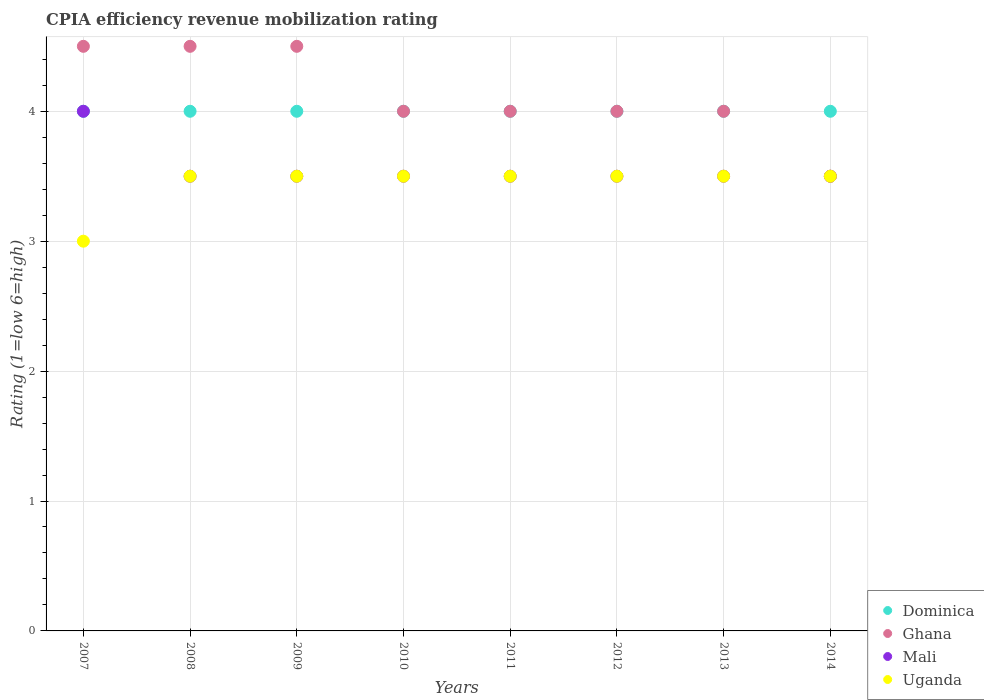How many different coloured dotlines are there?
Your answer should be very brief. 4. Across all years, what is the maximum CPIA rating in Dominica?
Your answer should be compact. 4. Across all years, what is the minimum CPIA rating in Dominica?
Offer a terse response. 4. In which year was the CPIA rating in Dominica minimum?
Keep it short and to the point. 2007. What is the difference between the CPIA rating in Uganda in 2013 and the CPIA rating in Dominica in 2012?
Offer a very short reply. -0.5. What is the average CPIA rating in Uganda per year?
Your answer should be very brief. 3.44. In the year 2011, what is the difference between the CPIA rating in Dominica and CPIA rating in Ghana?
Your answer should be very brief. 0. In how many years, is the CPIA rating in Mali greater than 3.4?
Ensure brevity in your answer.  8. What is the ratio of the CPIA rating in Dominica in 2010 to that in 2013?
Offer a terse response. 1. Is the difference between the CPIA rating in Dominica in 2008 and 2009 greater than the difference between the CPIA rating in Ghana in 2008 and 2009?
Provide a succinct answer. No. What is the difference between the highest and the second highest CPIA rating in Dominica?
Offer a very short reply. 0. Is the sum of the CPIA rating in Ghana in 2008 and 2013 greater than the maximum CPIA rating in Dominica across all years?
Keep it short and to the point. Yes. Does the CPIA rating in Uganda monotonically increase over the years?
Give a very brief answer. No. Is the CPIA rating in Uganda strictly greater than the CPIA rating in Mali over the years?
Provide a short and direct response. No. What is the difference between two consecutive major ticks on the Y-axis?
Offer a very short reply. 1. Are the values on the major ticks of Y-axis written in scientific E-notation?
Make the answer very short. No. Does the graph contain grids?
Offer a terse response. Yes. How are the legend labels stacked?
Your response must be concise. Vertical. What is the title of the graph?
Offer a terse response. CPIA efficiency revenue mobilization rating. What is the Rating (1=low 6=high) of Dominica in 2007?
Provide a short and direct response. 4. What is the Rating (1=low 6=high) in Ghana in 2007?
Your answer should be very brief. 4.5. What is the Rating (1=low 6=high) in Dominica in 2008?
Keep it short and to the point. 4. What is the Rating (1=low 6=high) in Mali in 2008?
Keep it short and to the point. 3.5. What is the Rating (1=low 6=high) in Uganda in 2008?
Provide a short and direct response. 3.5. What is the Rating (1=low 6=high) in Dominica in 2009?
Ensure brevity in your answer.  4. What is the Rating (1=low 6=high) in Uganda in 2009?
Your response must be concise. 3.5. What is the Rating (1=low 6=high) of Dominica in 2010?
Make the answer very short. 4. What is the Rating (1=low 6=high) in Mali in 2010?
Keep it short and to the point. 3.5. What is the Rating (1=low 6=high) in Uganda in 2010?
Your response must be concise. 3.5. What is the Rating (1=low 6=high) of Ghana in 2011?
Ensure brevity in your answer.  4. What is the Rating (1=low 6=high) of Uganda in 2011?
Ensure brevity in your answer.  3.5. What is the Rating (1=low 6=high) of Dominica in 2012?
Provide a short and direct response. 4. What is the Rating (1=low 6=high) in Uganda in 2012?
Make the answer very short. 3.5. What is the Rating (1=low 6=high) of Ghana in 2013?
Your answer should be compact. 4. What is the Rating (1=low 6=high) in Uganda in 2014?
Your response must be concise. 3.5. Across all years, what is the maximum Rating (1=low 6=high) in Dominica?
Offer a very short reply. 4. Across all years, what is the maximum Rating (1=low 6=high) in Ghana?
Ensure brevity in your answer.  4.5. Across all years, what is the maximum Rating (1=low 6=high) of Mali?
Offer a very short reply. 4. Across all years, what is the maximum Rating (1=low 6=high) in Uganda?
Keep it short and to the point. 3.5. Across all years, what is the minimum Rating (1=low 6=high) in Ghana?
Offer a very short reply. 3.5. Across all years, what is the minimum Rating (1=low 6=high) in Mali?
Provide a short and direct response. 3.5. Across all years, what is the minimum Rating (1=low 6=high) of Uganda?
Provide a succinct answer. 3. What is the total Rating (1=low 6=high) of Dominica in the graph?
Give a very brief answer. 32. What is the total Rating (1=low 6=high) in Ghana in the graph?
Offer a terse response. 33. What is the total Rating (1=low 6=high) of Uganda in the graph?
Keep it short and to the point. 27.5. What is the difference between the Rating (1=low 6=high) in Uganda in 2007 and that in 2008?
Provide a short and direct response. -0.5. What is the difference between the Rating (1=low 6=high) of Dominica in 2007 and that in 2009?
Offer a terse response. 0. What is the difference between the Rating (1=low 6=high) of Mali in 2007 and that in 2009?
Ensure brevity in your answer.  0.5. What is the difference between the Rating (1=low 6=high) of Uganda in 2007 and that in 2010?
Your answer should be very brief. -0.5. What is the difference between the Rating (1=low 6=high) of Dominica in 2007 and that in 2011?
Offer a very short reply. 0. What is the difference between the Rating (1=low 6=high) in Dominica in 2007 and that in 2012?
Your response must be concise. 0. What is the difference between the Rating (1=low 6=high) of Ghana in 2007 and that in 2012?
Your answer should be compact. 0.5. What is the difference between the Rating (1=low 6=high) in Ghana in 2007 and that in 2013?
Make the answer very short. 0.5. What is the difference between the Rating (1=low 6=high) of Uganda in 2007 and that in 2013?
Provide a short and direct response. -0.5. What is the difference between the Rating (1=low 6=high) in Dominica in 2008 and that in 2009?
Provide a short and direct response. 0. What is the difference between the Rating (1=low 6=high) in Ghana in 2008 and that in 2009?
Your response must be concise. 0. What is the difference between the Rating (1=low 6=high) in Uganda in 2008 and that in 2009?
Provide a succinct answer. 0. What is the difference between the Rating (1=low 6=high) in Dominica in 2008 and that in 2010?
Give a very brief answer. 0. What is the difference between the Rating (1=low 6=high) in Ghana in 2008 and that in 2010?
Provide a short and direct response. 0.5. What is the difference between the Rating (1=low 6=high) in Uganda in 2008 and that in 2010?
Ensure brevity in your answer.  0. What is the difference between the Rating (1=low 6=high) of Uganda in 2008 and that in 2011?
Provide a succinct answer. 0. What is the difference between the Rating (1=low 6=high) of Dominica in 2008 and that in 2012?
Offer a very short reply. 0. What is the difference between the Rating (1=low 6=high) of Ghana in 2008 and that in 2012?
Offer a terse response. 0.5. What is the difference between the Rating (1=low 6=high) of Uganda in 2008 and that in 2012?
Your answer should be very brief. 0. What is the difference between the Rating (1=low 6=high) of Ghana in 2008 and that in 2013?
Your answer should be very brief. 0.5. What is the difference between the Rating (1=low 6=high) of Uganda in 2008 and that in 2013?
Make the answer very short. 0. What is the difference between the Rating (1=low 6=high) in Dominica in 2008 and that in 2014?
Offer a very short reply. 0. What is the difference between the Rating (1=low 6=high) of Ghana in 2008 and that in 2014?
Your response must be concise. 1. What is the difference between the Rating (1=low 6=high) of Uganda in 2008 and that in 2014?
Provide a succinct answer. 0. What is the difference between the Rating (1=low 6=high) of Dominica in 2009 and that in 2010?
Ensure brevity in your answer.  0. What is the difference between the Rating (1=low 6=high) of Mali in 2009 and that in 2010?
Your answer should be very brief. 0. What is the difference between the Rating (1=low 6=high) of Uganda in 2009 and that in 2010?
Give a very brief answer. 0. What is the difference between the Rating (1=low 6=high) of Dominica in 2009 and that in 2011?
Make the answer very short. 0. What is the difference between the Rating (1=low 6=high) of Uganda in 2009 and that in 2011?
Keep it short and to the point. 0. What is the difference between the Rating (1=low 6=high) in Dominica in 2009 and that in 2012?
Provide a succinct answer. 0. What is the difference between the Rating (1=low 6=high) of Dominica in 2009 and that in 2013?
Offer a very short reply. 0. What is the difference between the Rating (1=low 6=high) of Ghana in 2009 and that in 2013?
Give a very brief answer. 0.5. What is the difference between the Rating (1=low 6=high) in Mali in 2009 and that in 2013?
Provide a short and direct response. 0. What is the difference between the Rating (1=low 6=high) in Uganda in 2009 and that in 2013?
Give a very brief answer. 0. What is the difference between the Rating (1=low 6=high) of Dominica in 2009 and that in 2014?
Offer a terse response. 0. What is the difference between the Rating (1=low 6=high) of Ghana in 2009 and that in 2014?
Give a very brief answer. 1. What is the difference between the Rating (1=low 6=high) in Mali in 2010 and that in 2011?
Provide a short and direct response. 0. What is the difference between the Rating (1=low 6=high) in Dominica in 2010 and that in 2012?
Offer a very short reply. 0. What is the difference between the Rating (1=low 6=high) of Ghana in 2010 and that in 2012?
Offer a very short reply. 0. What is the difference between the Rating (1=low 6=high) of Mali in 2010 and that in 2012?
Make the answer very short. 0. What is the difference between the Rating (1=low 6=high) in Uganda in 2010 and that in 2012?
Give a very brief answer. 0. What is the difference between the Rating (1=low 6=high) in Dominica in 2010 and that in 2013?
Provide a short and direct response. 0. What is the difference between the Rating (1=low 6=high) of Ghana in 2010 and that in 2013?
Give a very brief answer. 0. What is the difference between the Rating (1=low 6=high) in Dominica in 2010 and that in 2014?
Offer a very short reply. 0. What is the difference between the Rating (1=low 6=high) of Ghana in 2010 and that in 2014?
Offer a very short reply. 0.5. What is the difference between the Rating (1=low 6=high) of Ghana in 2011 and that in 2012?
Your answer should be very brief. 0. What is the difference between the Rating (1=low 6=high) in Mali in 2011 and that in 2012?
Your response must be concise. 0. What is the difference between the Rating (1=low 6=high) of Dominica in 2012 and that in 2013?
Offer a very short reply. 0. What is the difference between the Rating (1=low 6=high) of Ghana in 2012 and that in 2013?
Provide a succinct answer. 0. What is the difference between the Rating (1=low 6=high) of Uganda in 2012 and that in 2014?
Your answer should be very brief. 0. What is the difference between the Rating (1=low 6=high) in Dominica in 2013 and that in 2014?
Your answer should be very brief. 0. What is the difference between the Rating (1=low 6=high) in Mali in 2013 and that in 2014?
Offer a terse response. 0. What is the difference between the Rating (1=low 6=high) in Uganda in 2013 and that in 2014?
Keep it short and to the point. 0. What is the difference between the Rating (1=low 6=high) in Dominica in 2007 and the Rating (1=low 6=high) in Ghana in 2008?
Offer a terse response. -0.5. What is the difference between the Rating (1=low 6=high) in Dominica in 2007 and the Rating (1=low 6=high) in Mali in 2008?
Provide a short and direct response. 0.5. What is the difference between the Rating (1=low 6=high) in Dominica in 2007 and the Rating (1=low 6=high) in Uganda in 2008?
Give a very brief answer. 0.5. What is the difference between the Rating (1=low 6=high) in Ghana in 2007 and the Rating (1=low 6=high) in Uganda in 2008?
Your answer should be very brief. 1. What is the difference between the Rating (1=low 6=high) in Dominica in 2007 and the Rating (1=low 6=high) in Uganda in 2009?
Offer a terse response. 0.5. What is the difference between the Rating (1=low 6=high) in Ghana in 2007 and the Rating (1=low 6=high) in Mali in 2009?
Your answer should be compact. 1. What is the difference between the Rating (1=low 6=high) in Dominica in 2007 and the Rating (1=low 6=high) in Mali in 2010?
Offer a terse response. 0.5. What is the difference between the Rating (1=low 6=high) of Mali in 2007 and the Rating (1=low 6=high) of Uganda in 2010?
Give a very brief answer. 0.5. What is the difference between the Rating (1=low 6=high) in Dominica in 2007 and the Rating (1=low 6=high) in Ghana in 2011?
Your answer should be compact. 0. What is the difference between the Rating (1=low 6=high) of Dominica in 2007 and the Rating (1=low 6=high) of Mali in 2011?
Your answer should be very brief. 0.5. What is the difference between the Rating (1=low 6=high) of Dominica in 2007 and the Rating (1=low 6=high) of Uganda in 2011?
Your response must be concise. 0.5. What is the difference between the Rating (1=low 6=high) in Ghana in 2007 and the Rating (1=low 6=high) in Uganda in 2011?
Your response must be concise. 1. What is the difference between the Rating (1=low 6=high) in Mali in 2007 and the Rating (1=low 6=high) in Uganda in 2011?
Your answer should be compact. 0.5. What is the difference between the Rating (1=low 6=high) in Ghana in 2007 and the Rating (1=low 6=high) in Mali in 2012?
Give a very brief answer. 1. What is the difference between the Rating (1=low 6=high) in Ghana in 2007 and the Rating (1=low 6=high) in Uganda in 2012?
Keep it short and to the point. 1. What is the difference between the Rating (1=low 6=high) of Dominica in 2007 and the Rating (1=low 6=high) of Mali in 2013?
Provide a succinct answer. 0.5. What is the difference between the Rating (1=low 6=high) in Dominica in 2007 and the Rating (1=low 6=high) in Uganda in 2013?
Keep it short and to the point. 0.5. What is the difference between the Rating (1=low 6=high) of Ghana in 2007 and the Rating (1=low 6=high) of Mali in 2013?
Ensure brevity in your answer.  1. What is the difference between the Rating (1=low 6=high) in Dominica in 2008 and the Rating (1=low 6=high) in Mali in 2009?
Your answer should be compact. 0.5. What is the difference between the Rating (1=low 6=high) of Ghana in 2008 and the Rating (1=low 6=high) of Mali in 2009?
Your response must be concise. 1. What is the difference between the Rating (1=low 6=high) of Ghana in 2008 and the Rating (1=low 6=high) of Uganda in 2009?
Give a very brief answer. 1. What is the difference between the Rating (1=low 6=high) of Mali in 2008 and the Rating (1=low 6=high) of Uganda in 2009?
Ensure brevity in your answer.  0. What is the difference between the Rating (1=low 6=high) of Dominica in 2008 and the Rating (1=low 6=high) of Ghana in 2010?
Offer a very short reply. 0. What is the difference between the Rating (1=low 6=high) of Ghana in 2008 and the Rating (1=low 6=high) of Mali in 2010?
Offer a terse response. 1. What is the difference between the Rating (1=low 6=high) of Mali in 2008 and the Rating (1=low 6=high) of Uganda in 2010?
Ensure brevity in your answer.  0. What is the difference between the Rating (1=low 6=high) in Dominica in 2008 and the Rating (1=low 6=high) in Ghana in 2012?
Offer a very short reply. 0. What is the difference between the Rating (1=low 6=high) in Dominica in 2008 and the Rating (1=low 6=high) in Mali in 2012?
Provide a succinct answer. 0.5. What is the difference between the Rating (1=low 6=high) of Ghana in 2008 and the Rating (1=low 6=high) of Mali in 2012?
Make the answer very short. 1. What is the difference between the Rating (1=low 6=high) in Ghana in 2008 and the Rating (1=low 6=high) in Uganda in 2012?
Your answer should be compact. 1. What is the difference between the Rating (1=low 6=high) in Dominica in 2008 and the Rating (1=low 6=high) in Ghana in 2013?
Ensure brevity in your answer.  0. What is the difference between the Rating (1=low 6=high) of Dominica in 2008 and the Rating (1=low 6=high) of Uganda in 2013?
Make the answer very short. 0.5. What is the difference between the Rating (1=low 6=high) of Ghana in 2008 and the Rating (1=low 6=high) of Mali in 2013?
Make the answer very short. 1. What is the difference between the Rating (1=low 6=high) of Dominica in 2008 and the Rating (1=low 6=high) of Mali in 2014?
Make the answer very short. 0.5. What is the difference between the Rating (1=low 6=high) in Dominica in 2008 and the Rating (1=low 6=high) in Uganda in 2014?
Your answer should be compact. 0.5. What is the difference between the Rating (1=low 6=high) in Dominica in 2009 and the Rating (1=low 6=high) in Uganda in 2010?
Provide a short and direct response. 0.5. What is the difference between the Rating (1=low 6=high) of Ghana in 2009 and the Rating (1=low 6=high) of Mali in 2010?
Keep it short and to the point. 1. What is the difference between the Rating (1=low 6=high) in Ghana in 2009 and the Rating (1=low 6=high) in Uganda in 2010?
Make the answer very short. 1. What is the difference between the Rating (1=low 6=high) of Dominica in 2009 and the Rating (1=low 6=high) of Ghana in 2011?
Provide a succinct answer. 0. What is the difference between the Rating (1=low 6=high) of Dominica in 2009 and the Rating (1=low 6=high) of Mali in 2011?
Make the answer very short. 0.5. What is the difference between the Rating (1=low 6=high) in Dominica in 2009 and the Rating (1=low 6=high) in Uganda in 2011?
Provide a succinct answer. 0.5. What is the difference between the Rating (1=low 6=high) of Ghana in 2009 and the Rating (1=low 6=high) of Mali in 2011?
Your answer should be compact. 1. What is the difference between the Rating (1=low 6=high) of Ghana in 2009 and the Rating (1=low 6=high) of Uganda in 2011?
Provide a short and direct response. 1. What is the difference between the Rating (1=low 6=high) in Mali in 2009 and the Rating (1=low 6=high) in Uganda in 2011?
Your response must be concise. 0. What is the difference between the Rating (1=low 6=high) of Dominica in 2009 and the Rating (1=low 6=high) of Mali in 2012?
Your response must be concise. 0.5. What is the difference between the Rating (1=low 6=high) of Ghana in 2009 and the Rating (1=low 6=high) of Mali in 2012?
Provide a short and direct response. 1. What is the difference between the Rating (1=low 6=high) of Ghana in 2009 and the Rating (1=low 6=high) of Uganda in 2012?
Your response must be concise. 1. What is the difference between the Rating (1=low 6=high) in Dominica in 2009 and the Rating (1=low 6=high) in Ghana in 2013?
Your answer should be very brief. 0. What is the difference between the Rating (1=low 6=high) of Ghana in 2009 and the Rating (1=low 6=high) of Uganda in 2013?
Your answer should be compact. 1. What is the difference between the Rating (1=low 6=high) of Mali in 2009 and the Rating (1=low 6=high) of Uganda in 2013?
Make the answer very short. 0. What is the difference between the Rating (1=low 6=high) in Dominica in 2009 and the Rating (1=low 6=high) in Ghana in 2014?
Make the answer very short. 0.5. What is the difference between the Rating (1=low 6=high) in Ghana in 2009 and the Rating (1=low 6=high) in Mali in 2014?
Provide a short and direct response. 1. What is the difference between the Rating (1=low 6=high) of Ghana in 2009 and the Rating (1=low 6=high) of Uganda in 2014?
Your answer should be very brief. 1. What is the difference between the Rating (1=low 6=high) in Dominica in 2010 and the Rating (1=low 6=high) in Ghana in 2011?
Make the answer very short. 0. What is the difference between the Rating (1=low 6=high) of Mali in 2010 and the Rating (1=low 6=high) of Uganda in 2011?
Offer a very short reply. 0. What is the difference between the Rating (1=low 6=high) of Dominica in 2010 and the Rating (1=low 6=high) of Uganda in 2012?
Make the answer very short. 0.5. What is the difference between the Rating (1=low 6=high) in Ghana in 2010 and the Rating (1=low 6=high) in Uganda in 2012?
Provide a succinct answer. 0.5. What is the difference between the Rating (1=low 6=high) in Dominica in 2010 and the Rating (1=low 6=high) in Ghana in 2013?
Offer a terse response. 0. What is the difference between the Rating (1=low 6=high) of Dominica in 2010 and the Rating (1=low 6=high) of Mali in 2013?
Provide a short and direct response. 0.5. What is the difference between the Rating (1=low 6=high) in Ghana in 2010 and the Rating (1=low 6=high) in Mali in 2013?
Make the answer very short. 0.5. What is the difference between the Rating (1=low 6=high) of Ghana in 2010 and the Rating (1=low 6=high) of Uganda in 2013?
Your response must be concise. 0.5. What is the difference between the Rating (1=low 6=high) of Dominica in 2010 and the Rating (1=low 6=high) of Uganda in 2014?
Make the answer very short. 0.5. What is the difference between the Rating (1=low 6=high) in Ghana in 2010 and the Rating (1=low 6=high) in Mali in 2014?
Ensure brevity in your answer.  0.5. What is the difference between the Rating (1=low 6=high) in Mali in 2010 and the Rating (1=low 6=high) in Uganda in 2014?
Offer a very short reply. 0. What is the difference between the Rating (1=low 6=high) of Dominica in 2011 and the Rating (1=low 6=high) of Mali in 2012?
Keep it short and to the point. 0.5. What is the difference between the Rating (1=low 6=high) in Dominica in 2011 and the Rating (1=low 6=high) in Uganda in 2012?
Your answer should be very brief. 0.5. What is the difference between the Rating (1=low 6=high) of Mali in 2011 and the Rating (1=low 6=high) of Uganda in 2012?
Your answer should be very brief. 0. What is the difference between the Rating (1=low 6=high) of Dominica in 2011 and the Rating (1=low 6=high) of Ghana in 2013?
Your response must be concise. 0. What is the difference between the Rating (1=low 6=high) in Dominica in 2011 and the Rating (1=low 6=high) in Mali in 2013?
Your response must be concise. 0.5. What is the difference between the Rating (1=low 6=high) in Dominica in 2011 and the Rating (1=low 6=high) in Uganda in 2013?
Your response must be concise. 0.5. What is the difference between the Rating (1=low 6=high) of Ghana in 2011 and the Rating (1=low 6=high) of Uganda in 2013?
Your answer should be very brief. 0.5. What is the difference between the Rating (1=low 6=high) in Dominica in 2011 and the Rating (1=low 6=high) in Uganda in 2014?
Offer a very short reply. 0.5. What is the difference between the Rating (1=low 6=high) of Ghana in 2011 and the Rating (1=low 6=high) of Mali in 2014?
Ensure brevity in your answer.  0.5. What is the difference between the Rating (1=low 6=high) of Ghana in 2011 and the Rating (1=low 6=high) of Uganda in 2014?
Give a very brief answer. 0.5. What is the difference between the Rating (1=low 6=high) of Mali in 2011 and the Rating (1=low 6=high) of Uganda in 2014?
Offer a very short reply. 0. What is the difference between the Rating (1=low 6=high) in Dominica in 2012 and the Rating (1=low 6=high) in Mali in 2013?
Keep it short and to the point. 0.5. What is the difference between the Rating (1=low 6=high) of Ghana in 2012 and the Rating (1=low 6=high) of Uganda in 2013?
Give a very brief answer. 0.5. What is the difference between the Rating (1=low 6=high) in Dominica in 2012 and the Rating (1=low 6=high) in Mali in 2014?
Your answer should be compact. 0.5. What is the difference between the Rating (1=low 6=high) of Dominica in 2012 and the Rating (1=low 6=high) of Uganda in 2014?
Give a very brief answer. 0.5. What is the difference between the Rating (1=low 6=high) in Ghana in 2012 and the Rating (1=low 6=high) in Uganda in 2014?
Your response must be concise. 0.5. What is the difference between the Rating (1=low 6=high) in Dominica in 2013 and the Rating (1=low 6=high) in Ghana in 2014?
Give a very brief answer. 0.5. What is the difference between the Rating (1=low 6=high) of Dominica in 2013 and the Rating (1=low 6=high) of Mali in 2014?
Provide a short and direct response. 0.5. What is the difference between the Rating (1=low 6=high) in Dominica in 2013 and the Rating (1=low 6=high) in Uganda in 2014?
Your answer should be compact. 0.5. What is the average Rating (1=low 6=high) in Ghana per year?
Offer a terse response. 4.12. What is the average Rating (1=low 6=high) in Mali per year?
Your response must be concise. 3.56. What is the average Rating (1=low 6=high) in Uganda per year?
Your answer should be very brief. 3.44. In the year 2007, what is the difference between the Rating (1=low 6=high) of Dominica and Rating (1=low 6=high) of Ghana?
Make the answer very short. -0.5. In the year 2007, what is the difference between the Rating (1=low 6=high) in Dominica and Rating (1=low 6=high) in Uganda?
Provide a short and direct response. 1. In the year 2008, what is the difference between the Rating (1=low 6=high) in Dominica and Rating (1=low 6=high) in Ghana?
Offer a terse response. -0.5. In the year 2008, what is the difference between the Rating (1=low 6=high) in Dominica and Rating (1=low 6=high) in Uganda?
Make the answer very short. 0.5. In the year 2008, what is the difference between the Rating (1=low 6=high) in Mali and Rating (1=low 6=high) in Uganda?
Make the answer very short. 0. In the year 2009, what is the difference between the Rating (1=low 6=high) in Dominica and Rating (1=low 6=high) in Ghana?
Keep it short and to the point. -0.5. In the year 2009, what is the difference between the Rating (1=low 6=high) of Dominica and Rating (1=low 6=high) of Mali?
Your answer should be very brief. 0.5. In the year 2009, what is the difference between the Rating (1=low 6=high) in Ghana and Rating (1=low 6=high) in Uganda?
Ensure brevity in your answer.  1. In the year 2009, what is the difference between the Rating (1=low 6=high) in Mali and Rating (1=low 6=high) in Uganda?
Make the answer very short. 0. In the year 2010, what is the difference between the Rating (1=low 6=high) of Dominica and Rating (1=low 6=high) of Mali?
Your answer should be compact. 0.5. In the year 2010, what is the difference between the Rating (1=low 6=high) in Dominica and Rating (1=low 6=high) in Uganda?
Make the answer very short. 0.5. In the year 2010, what is the difference between the Rating (1=low 6=high) in Ghana and Rating (1=low 6=high) in Mali?
Your answer should be compact. 0.5. In the year 2010, what is the difference between the Rating (1=low 6=high) of Ghana and Rating (1=low 6=high) of Uganda?
Provide a succinct answer. 0.5. In the year 2012, what is the difference between the Rating (1=low 6=high) in Dominica and Rating (1=low 6=high) in Ghana?
Give a very brief answer. 0. In the year 2012, what is the difference between the Rating (1=low 6=high) of Dominica and Rating (1=low 6=high) of Uganda?
Make the answer very short. 0.5. In the year 2012, what is the difference between the Rating (1=low 6=high) in Ghana and Rating (1=low 6=high) in Mali?
Offer a very short reply. 0.5. In the year 2012, what is the difference between the Rating (1=low 6=high) in Ghana and Rating (1=low 6=high) in Uganda?
Provide a short and direct response. 0.5. In the year 2012, what is the difference between the Rating (1=low 6=high) in Mali and Rating (1=low 6=high) in Uganda?
Provide a short and direct response. 0. In the year 2013, what is the difference between the Rating (1=low 6=high) in Dominica and Rating (1=low 6=high) in Mali?
Your answer should be very brief. 0.5. In the year 2013, what is the difference between the Rating (1=low 6=high) of Dominica and Rating (1=low 6=high) of Uganda?
Keep it short and to the point. 0.5. In the year 2013, what is the difference between the Rating (1=low 6=high) of Ghana and Rating (1=low 6=high) of Mali?
Provide a short and direct response. 0.5. In the year 2013, what is the difference between the Rating (1=low 6=high) of Ghana and Rating (1=low 6=high) of Uganda?
Make the answer very short. 0.5. In the year 2013, what is the difference between the Rating (1=low 6=high) of Mali and Rating (1=low 6=high) of Uganda?
Give a very brief answer. 0. In the year 2014, what is the difference between the Rating (1=low 6=high) in Dominica and Rating (1=low 6=high) in Ghana?
Your answer should be very brief. 0.5. In the year 2014, what is the difference between the Rating (1=low 6=high) in Dominica and Rating (1=low 6=high) in Mali?
Keep it short and to the point. 0.5. In the year 2014, what is the difference between the Rating (1=low 6=high) of Dominica and Rating (1=low 6=high) of Uganda?
Your answer should be compact. 0.5. In the year 2014, what is the difference between the Rating (1=low 6=high) of Mali and Rating (1=low 6=high) of Uganda?
Provide a succinct answer. 0. What is the ratio of the Rating (1=low 6=high) in Dominica in 2007 to that in 2009?
Your answer should be compact. 1. What is the ratio of the Rating (1=low 6=high) in Ghana in 2007 to that in 2009?
Ensure brevity in your answer.  1. What is the ratio of the Rating (1=low 6=high) of Mali in 2007 to that in 2009?
Your answer should be compact. 1.14. What is the ratio of the Rating (1=low 6=high) in Uganda in 2007 to that in 2009?
Your response must be concise. 0.86. What is the ratio of the Rating (1=low 6=high) of Ghana in 2007 to that in 2010?
Your answer should be very brief. 1.12. What is the ratio of the Rating (1=low 6=high) in Uganda in 2007 to that in 2010?
Keep it short and to the point. 0.86. What is the ratio of the Rating (1=low 6=high) of Ghana in 2007 to that in 2011?
Your response must be concise. 1.12. What is the ratio of the Rating (1=low 6=high) of Uganda in 2007 to that in 2011?
Provide a succinct answer. 0.86. What is the ratio of the Rating (1=low 6=high) of Ghana in 2007 to that in 2012?
Offer a very short reply. 1.12. What is the ratio of the Rating (1=low 6=high) of Mali in 2007 to that in 2012?
Provide a succinct answer. 1.14. What is the ratio of the Rating (1=low 6=high) in Ghana in 2007 to that in 2013?
Offer a terse response. 1.12. What is the ratio of the Rating (1=low 6=high) of Mali in 2007 to that in 2013?
Provide a succinct answer. 1.14. What is the ratio of the Rating (1=low 6=high) in Ghana in 2007 to that in 2014?
Give a very brief answer. 1.29. What is the ratio of the Rating (1=low 6=high) of Mali in 2007 to that in 2014?
Provide a short and direct response. 1.14. What is the ratio of the Rating (1=low 6=high) of Uganda in 2007 to that in 2014?
Give a very brief answer. 0.86. What is the ratio of the Rating (1=low 6=high) of Dominica in 2008 to that in 2009?
Provide a succinct answer. 1. What is the ratio of the Rating (1=low 6=high) in Uganda in 2008 to that in 2009?
Provide a short and direct response. 1. What is the ratio of the Rating (1=low 6=high) of Ghana in 2008 to that in 2011?
Ensure brevity in your answer.  1.12. What is the ratio of the Rating (1=low 6=high) in Ghana in 2008 to that in 2012?
Offer a very short reply. 1.12. What is the ratio of the Rating (1=low 6=high) of Dominica in 2008 to that in 2014?
Provide a short and direct response. 1. What is the ratio of the Rating (1=low 6=high) in Ghana in 2008 to that in 2014?
Give a very brief answer. 1.29. What is the ratio of the Rating (1=low 6=high) in Mali in 2008 to that in 2014?
Provide a short and direct response. 1. What is the ratio of the Rating (1=low 6=high) in Uganda in 2008 to that in 2014?
Your answer should be very brief. 1. What is the ratio of the Rating (1=low 6=high) of Dominica in 2009 to that in 2010?
Provide a succinct answer. 1. What is the ratio of the Rating (1=low 6=high) in Dominica in 2009 to that in 2011?
Offer a very short reply. 1. What is the ratio of the Rating (1=low 6=high) of Mali in 2009 to that in 2011?
Provide a succinct answer. 1. What is the ratio of the Rating (1=low 6=high) in Uganda in 2009 to that in 2011?
Ensure brevity in your answer.  1. What is the ratio of the Rating (1=low 6=high) in Uganda in 2009 to that in 2012?
Ensure brevity in your answer.  1. What is the ratio of the Rating (1=low 6=high) in Dominica in 2009 to that in 2013?
Your answer should be very brief. 1. What is the ratio of the Rating (1=low 6=high) in Ghana in 2009 to that in 2013?
Your answer should be compact. 1.12. What is the ratio of the Rating (1=low 6=high) in Ghana in 2009 to that in 2014?
Your response must be concise. 1.29. What is the ratio of the Rating (1=low 6=high) of Mali in 2009 to that in 2014?
Your answer should be very brief. 1. What is the ratio of the Rating (1=low 6=high) in Dominica in 2010 to that in 2012?
Your answer should be compact. 1. What is the ratio of the Rating (1=low 6=high) of Uganda in 2010 to that in 2012?
Your response must be concise. 1. What is the ratio of the Rating (1=low 6=high) in Uganda in 2010 to that in 2013?
Keep it short and to the point. 1. What is the ratio of the Rating (1=low 6=high) of Dominica in 2010 to that in 2014?
Your answer should be very brief. 1. What is the ratio of the Rating (1=low 6=high) of Mali in 2010 to that in 2014?
Your response must be concise. 1. What is the ratio of the Rating (1=low 6=high) in Uganda in 2011 to that in 2013?
Make the answer very short. 1. What is the ratio of the Rating (1=low 6=high) in Dominica in 2011 to that in 2014?
Offer a terse response. 1. What is the ratio of the Rating (1=low 6=high) in Ghana in 2011 to that in 2014?
Make the answer very short. 1.14. What is the ratio of the Rating (1=low 6=high) in Dominica in 2012 to that in 2013?
Provide a succinct answer. 1. What is the ratio of the Rating (1=low 6=high) of Ghana in 2012 to that in 2013?
Your answer should be compact. 1. What is the ratio of the Rating (1=low 6=high) of Uganda in 2012 to that in 2013?
Make the answer very short. 1. What is the ratio of the Rating (1=low 6=high) in Mali in 2012 to that in 2014?
Give a very brief answer. 1. What is the ratio of the Rating (1=low 6=high) in Ghana in 2013 to that in 2014?
Your answer should be very brief. 1.14. What is the difference between the highest and the second highest Rating (1=low 6=high) of Mali?
Offer a terse response. 0.5. What is the difference between the highest and the lowest Rating (1=low 6=high) in Dominica?
Provide a short and direct response. 0. What is the difference between the highest and the lowest Rating (1=low 6=high) in Ghana?
Ensure brevity in your answer.  1. What is the difference between the highest and the lowest Rating (1=low 6=high) of Uganda?
Provide a short and direct response. 0.5. 